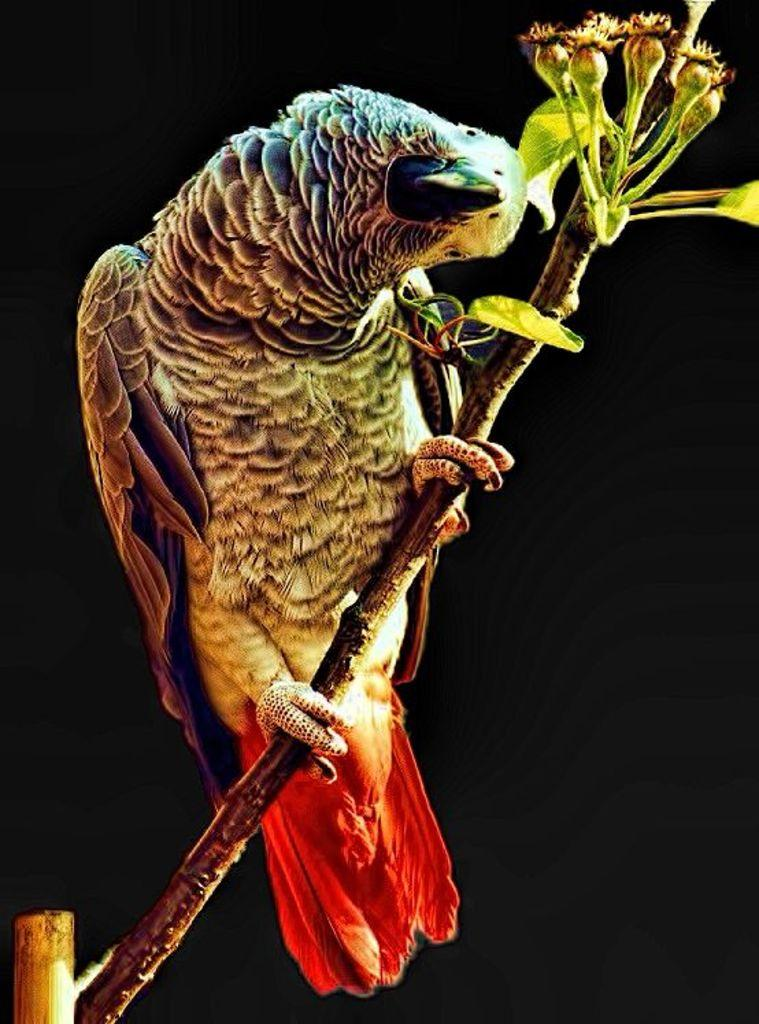What type of animal can be seen in the image? There is a bird in the image. What is the bird perched on in the image? The bird is perched on a tree branch in the image. What type of cakes are being sold in the shop in the image? There is no shop or cakes present in the image; it only features a bird on a tree branch. 